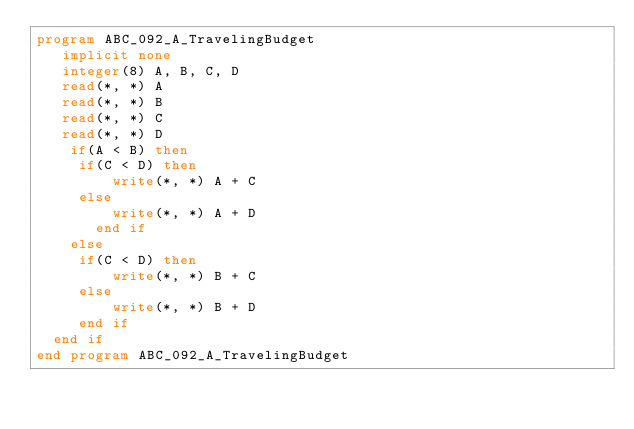Convert code to text. <code><loc_0><loc_0><loc_500><loc_500><_FORTRAN_>program ABC_092_A_TravelingBudget
   implicit none
   integer(8) A, B, C, D
   read(*, *) A
   read(*, *) B
   read(*, *) C
   read(*, *) D
    if(A < B) then
	   if(C < D) then
	       write(*, *) A + C
	   else 
	       write(*, *) A + D	      
       end if
    else 
	   if(C < D) then
	       write(*, *) B + C
	   else 
	       write(*, *) B + D
	   end if
	end if
end program ABC_092_A_TravelingBudget</code> 